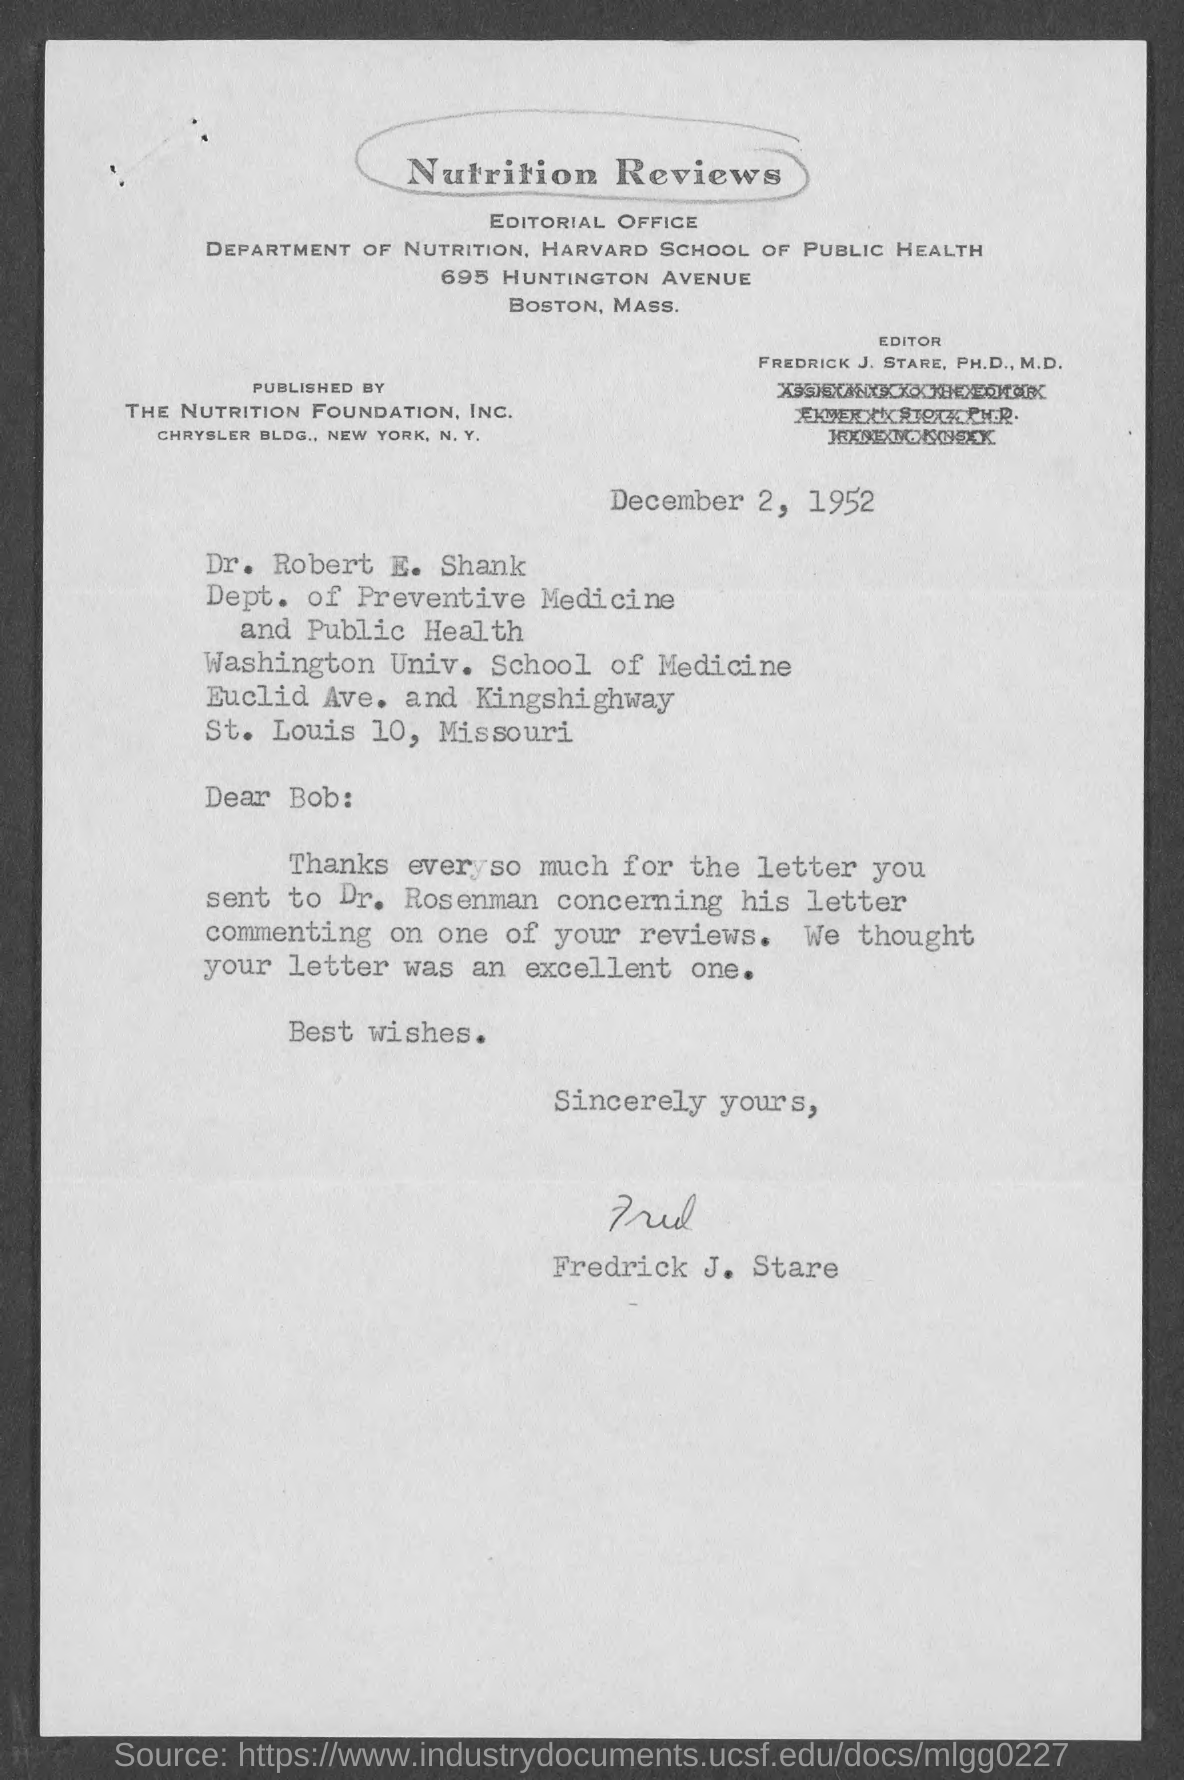Draw attention to some important aspects in this diagram. The editor is Fredrick J. Stare, Ph.D., M.D., a highly qualified and respected individual with expertise in their field. The memorandum is from Frederick J. Stare. The Memorandum was dated December 2, 1952. The top of the document reads 'Nutrition Reviews.' 